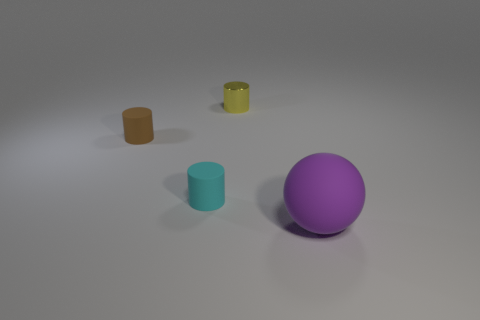What is the size of the purple object that is the same material as the cyan cylinder?
Offer a very short reply. Large. There is a yellow thing that is behind the small cyan rubber cylinder; does it have the same shape as the tiny brown matte thing?
Give a very brief answer. Yes. What number of rubber things are green cubes or tiny cyan cylinders?
Your response must be concise. 1. Is there a cyan matte thing that has the same size as the yellow cylinder?
Your answer should be very brief. Yes. Are there more balls that are behind the tiny brown thing than tiny brown metallic cylinders?
Make the answer very short. No. What number of small things are either shiny objects or brown things?
Make the answer very short. 2. How many other big rubber things are the same shape as the large thing?
Provide a short and direct response. 0. The tiny thing that is in front of the tiny matte thing on the left side of the tiny cyan cylinder is made of what material?
Give a very brief answer. Rubber. What size is the rubber cylinder that is behind the small cyan cylinder?
Ensure brevity in your answer.  Small. How many yellow things are either small metallic cylinders or matte objects?
Provide a short and direct response. 1. 